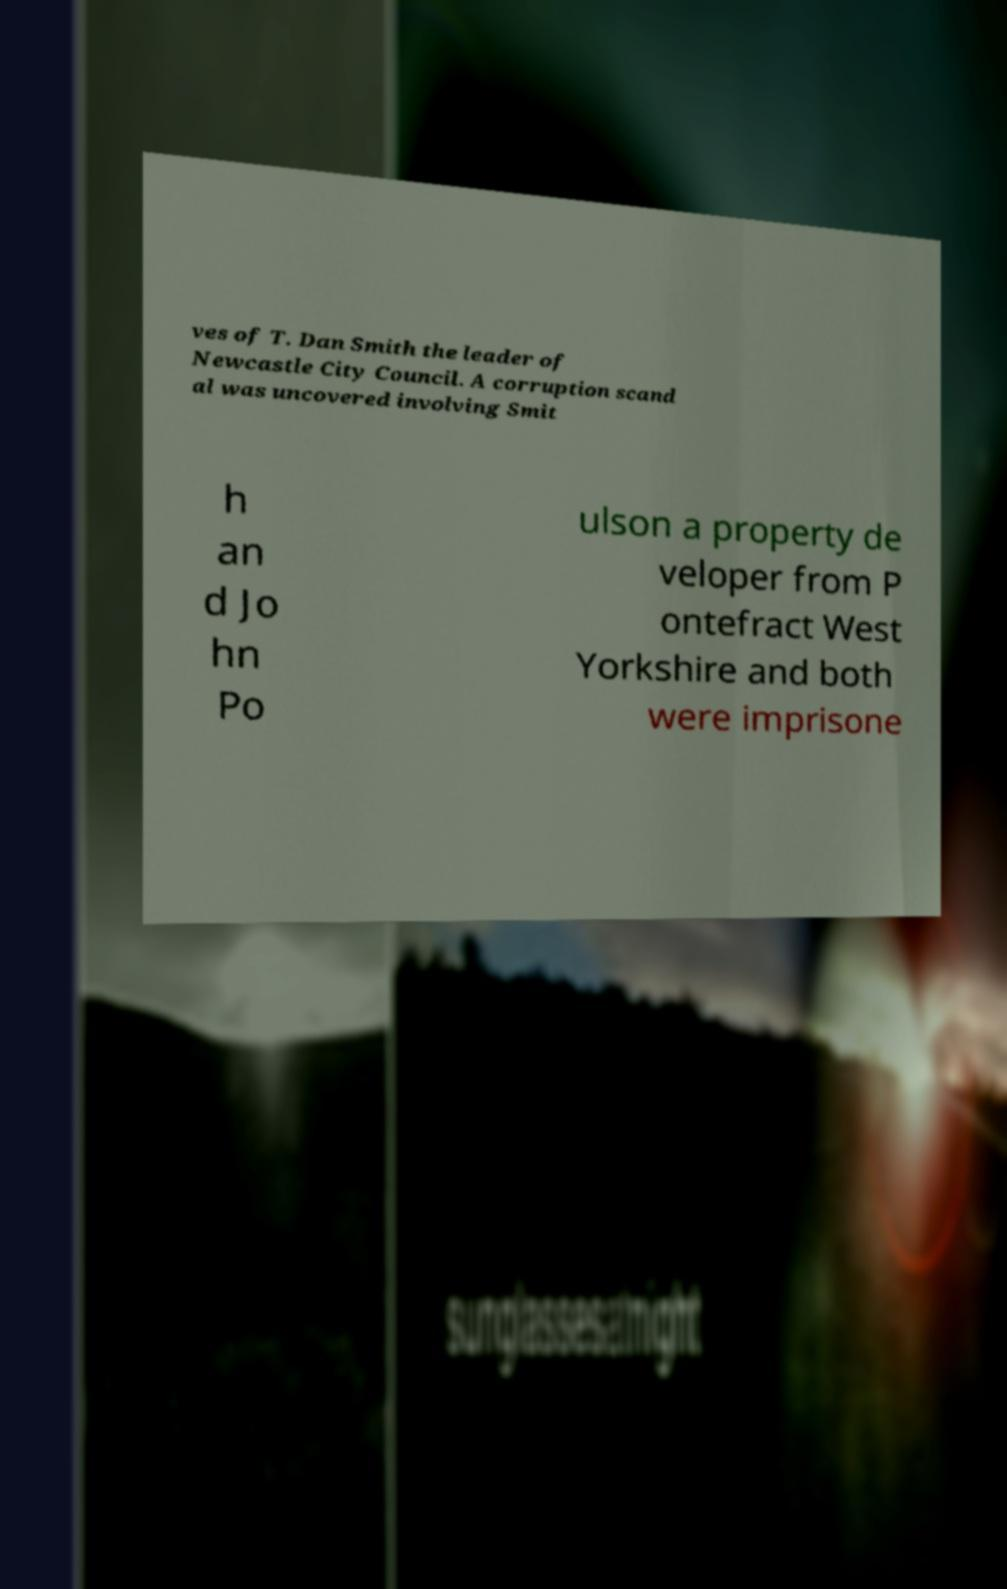What messages or text are displayed in this image? I need them in a readable, typed format. ves of T. Dan Smith the leader of Newcastle City Council. A corruption scand al was uncovered involving Smit h an d Jo hn Po ulson a property de veloper from P ontefract West Yorkshire and both were imprisone 